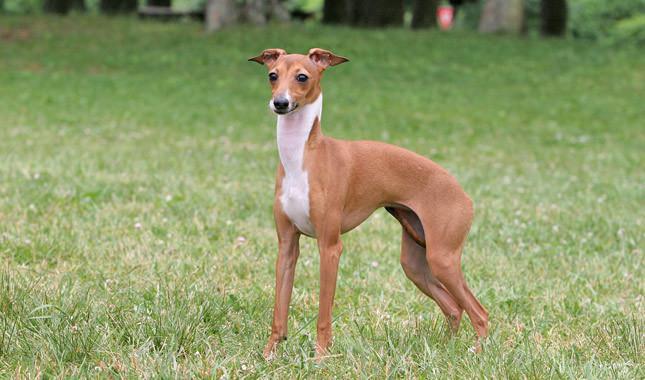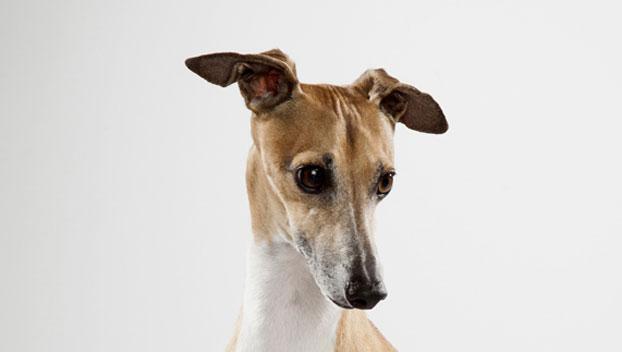The first image is the image on the left, the second image is the image on the right. Analyze the images presented: Is the assertion "In one of the images, there is a brown and white dog standing in grass" valid? Answer yes or no. Yes. 